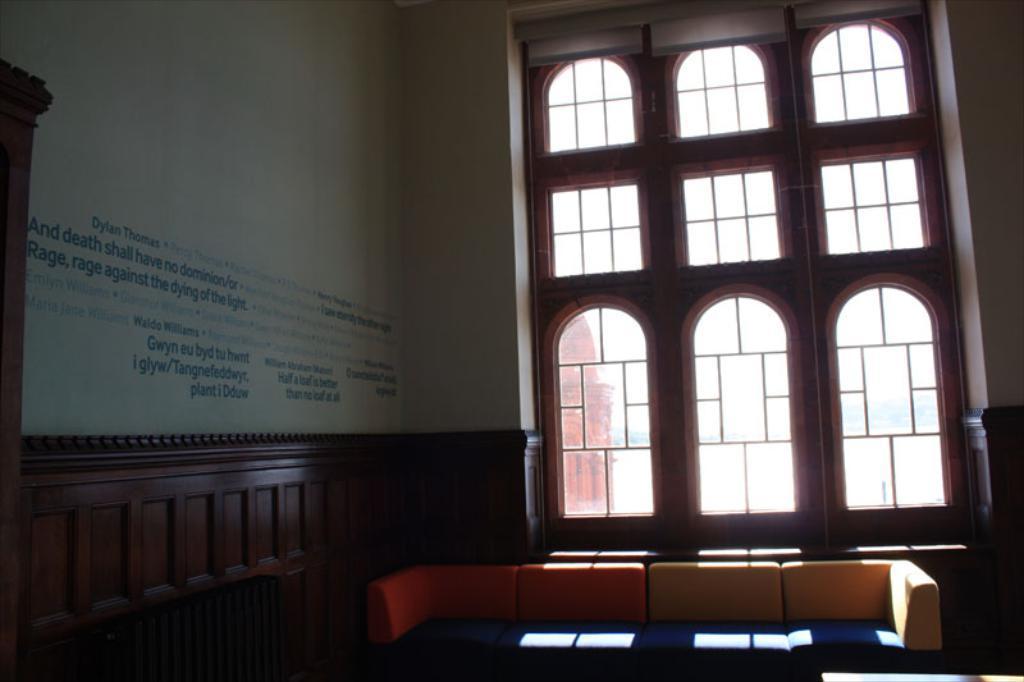In one or two sentences, can you explain what this image depicts? In this image I can see the inner part of the building. Inside the building I can see the couch and window. To the left I can see the text written on the wall. 